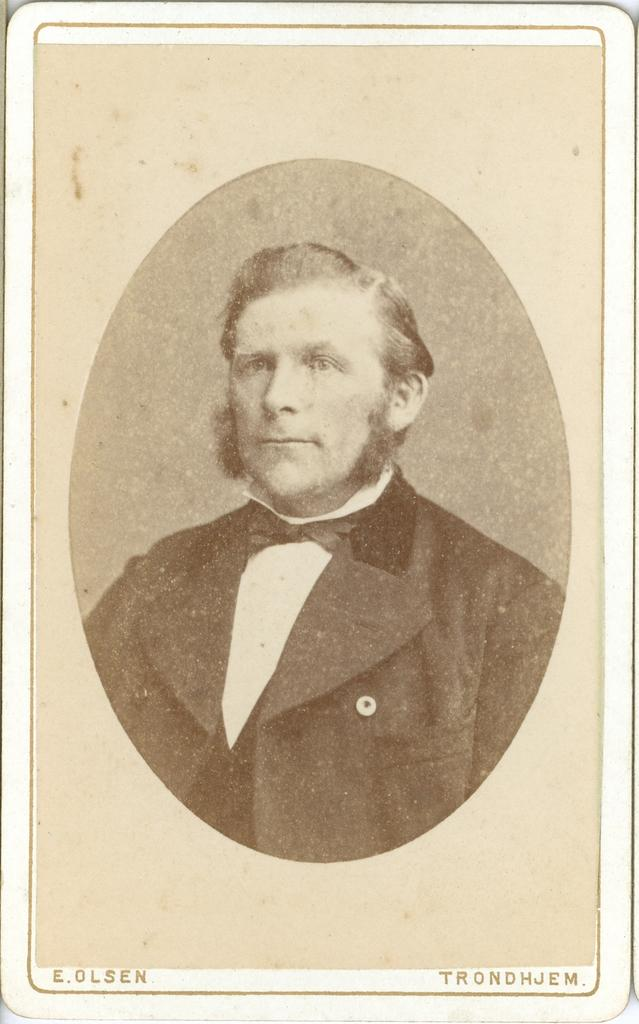What is the main subject in the image? There is a frame in the image. How many ladybugs can be seen crawling on the frame in the image? There are no ladybugs present in the image; it only features a frame. 